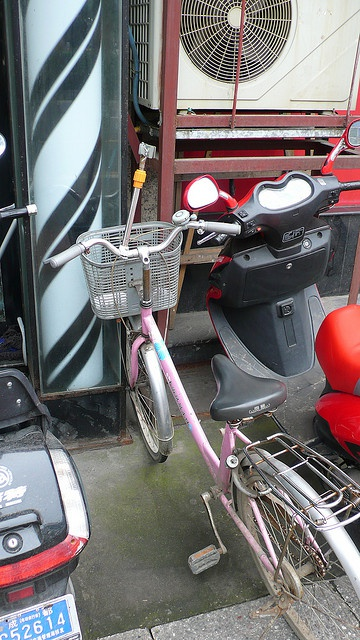Describe the objects in this image and their specific colors. I can see bicycle in black, gray, darkgray, and lightgray tones, motorcycle in black, gray, darkgray, and white tones, and motorcycle in black, gray, white, and darkgray tones in this image. 